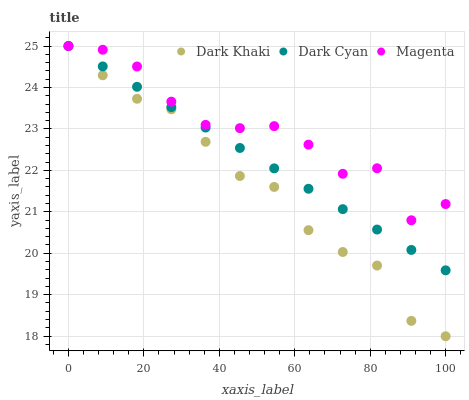Does Dark Khaki have the minimum area under the curve?
Answer yes or no. Yes. Does Magenta have the maximum area under the curve?
Answer yes or no. Yes. Does Dark Cyan have the minimum area under the curve?
Answer yes or no. No. Does Dark Cyan have the maximum area under the curve?
Answer yes or no. No. Is Dark Cyan the smoothest?
Answer yes or no. Yes. Is Magenta the roughest?
Answer yes or no. Yes. Is Magenta the smoothest?
Answer yes or no. No. Is Dark Cyan the roughest?
Answer yes or no. No. Does Dark Khaki have the lowest value?
Answer yes or no. Yes. Does Dark Cyan have the lowest value?
Answer yes or no. No. Does Magenta have the highest value?
Answer yes or no. Yes. Does Magenta intersect Dark Khaki?
Answer yes or no. Yes. Is Magenta less than Dark Khaki?
Answer yes or no. No. Is Magenta greater than Dark Khaki?
Answer yes or no. No. 